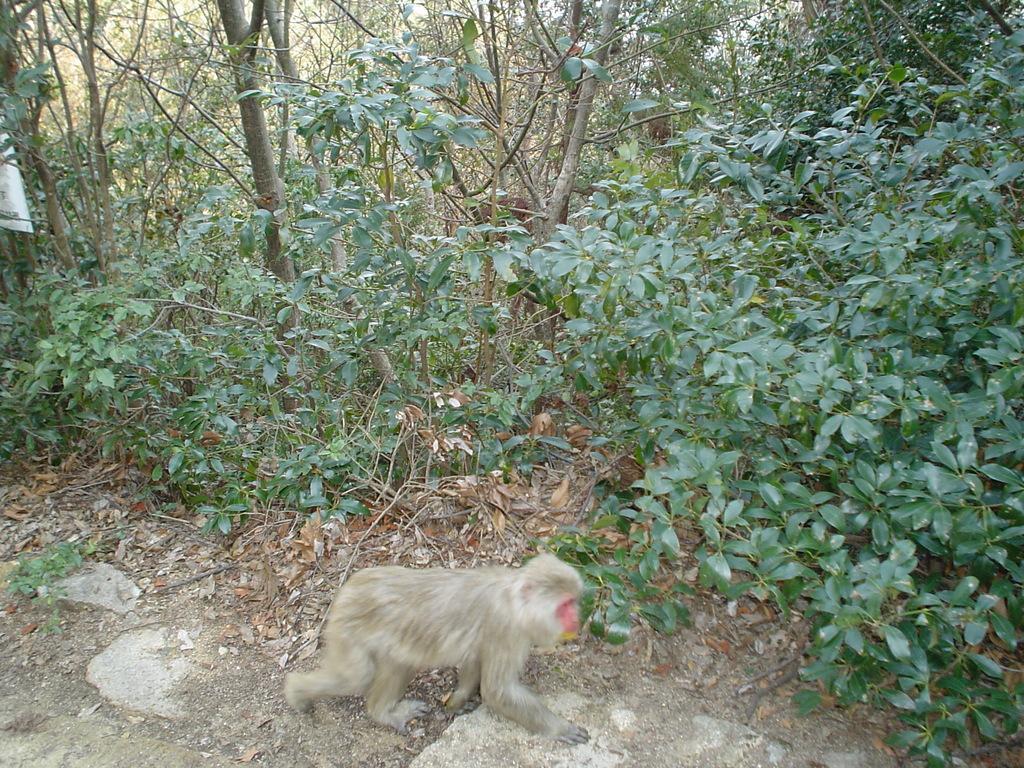Could you give a brief overview of what you see in this image? Here we can see monkey, plants and trees. 